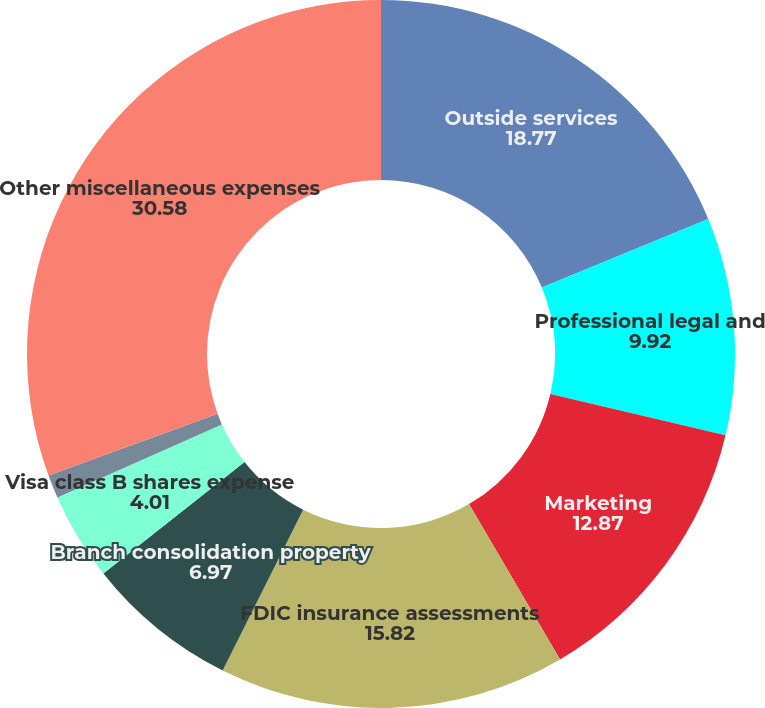Convert chart to OTSL. <chart><loc_0><loc_0><loc_500><loc_500><pie_chart><fcel>Outside services<fcel>Professional legal and<fcel>Marketing<fcel>FDIC insurance assessments<fcel>Branch consolidation property<fcel>Visa class B shares expense<fcel>Provision (credit) for<fcel>Other miscellaneous expenses<nl><fcel>18.77%<fcel>9.92%<fcel>12.87%<fcel>15.82%<fcel>6.97%<fcel>4.01%<fcel>1.06%<fcel>30.58%<nl></chart> 